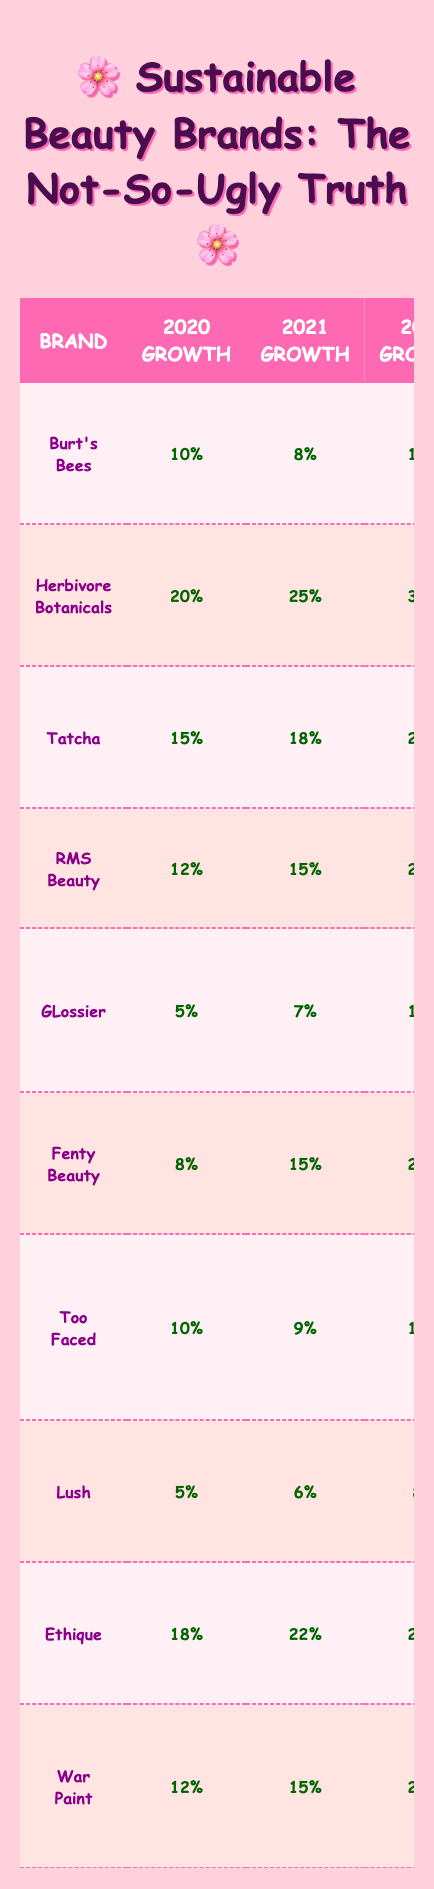What is the growth rate of Herbivore Botanicals in 2023? The table shows the growth rate for Herbivore Botanicals in 2023 as 35%.
Answer: 35% Which brand had the highest average growth rate from 2020 to 2023? To find the average growth rate, add the growth rates for each year: Herbivore Botanicals (20 + 25 + 30 + 35 = 110) gives an average of 27.5%. That is the highest among all brands.
Answer: Herbivore Botanicals Did Fenty Beauty's growth rate in 2023 increase or decrease compared to 2022? The growth rate for Fenty Beauty in 2023 is 18%, while in 2022 it was 20%. Since 18% is less than 20%, it decreased.
Answer: Decrease Which brand had the smallest growth rate in 2020? Looking at the 2020 growth rates, GLossier has the smallest growth rate at 5%.
Answer: GLossier What is the total growth rate for War Paint from 2020 to 2023? For War Paint, the growth rates are 12% (2020) + 15% (2021) + 21% (2022) + 26% (2023), which totals to 74%.
Answer: 74% What was the growth rate trend for RMS Beauty from 2020 to 2023? The growth rates for RMS Beauty are increasing each year: 12% in 2020, 15% in 2021, 20% in 2022, and 27% in 2023. This indicates a consistent upward trend.
Answer: Increasing Is Lush's growth in 2023 higher than that of Burt's Bees? Lush's growth in 2023 is 9%, while Burt's Bees' is 15%. Since 9% is less than 15%, Lush's growth is not higher.
Answer: No What was the difference in growth rate between Tatcha in 2020 and 2023? Tatcha had a growth rate of 15% in 2020 and 25% in 2023. The difference is 25% - 15% = 10%.
Answer: 10% Which brand had a growth rate of less than 10% during any of the years presented? GLossier had a growth rate of 5% in 2020 and 7% in 2021, both less than 10%.
Answer: GLossier Identify the year in which Ethique had the highest growth rate. In the table, Ethique's growth rates show it had the highest growth in 2023 at 30%.
Answer: 2023 